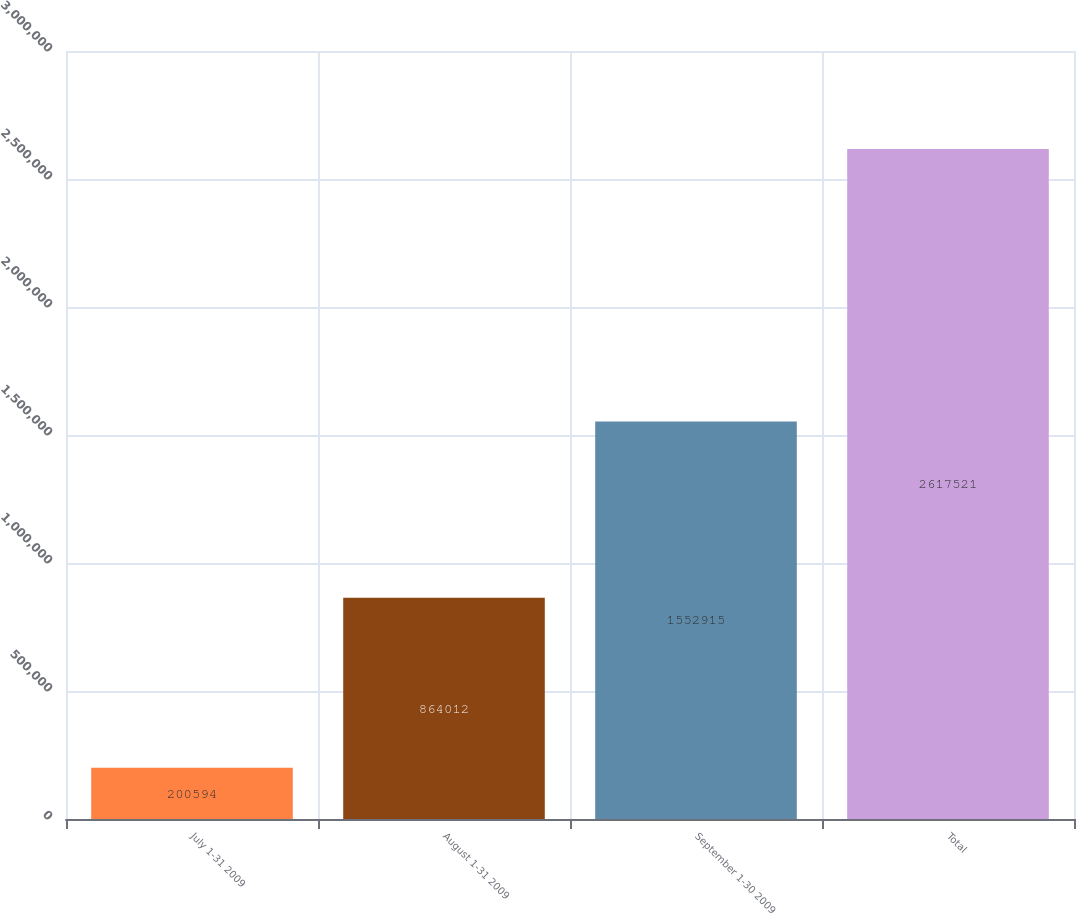<chart> <loc_0><loc_0><loc_500><loc_500><bar_chart><fcel>July 1-31 2009<fcel>August 1-31 2009<fcel>September 1-30 2009<fcel>Total<nl><fcel>200594<fcel>864012<fcel>1.55292e+06<fcel>2.61752e+06<nl></chart> 